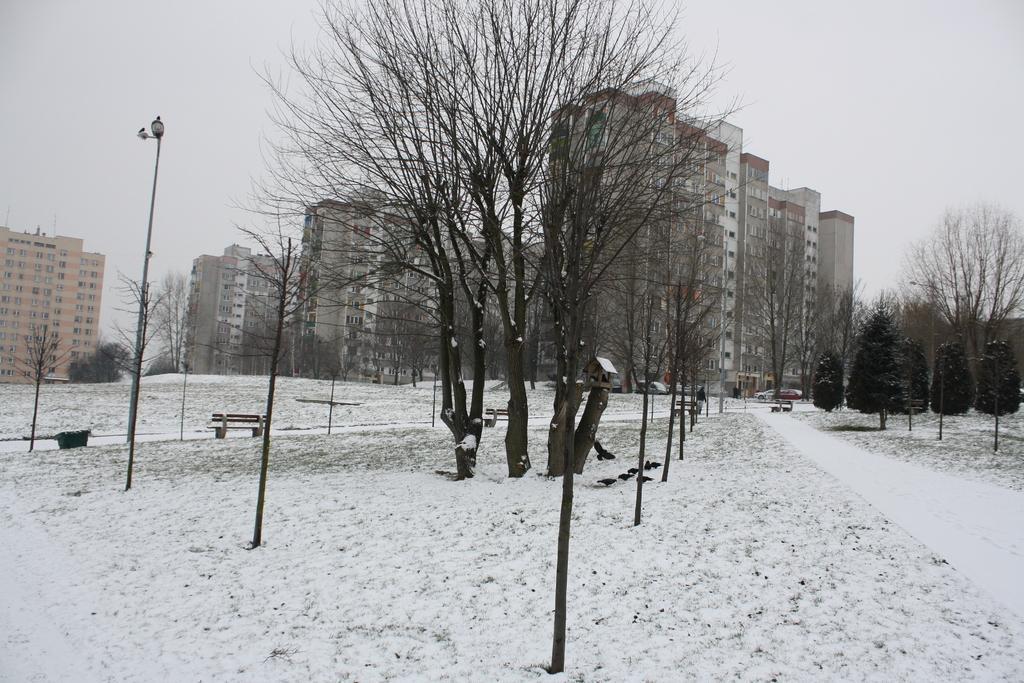In one or two sentences, can you explain what this image depicts? In this image, we can see trees, street lights, poles, walkways, benches, snow and birds. In the background, we can see trees, buildings, vehicles and the sky. 